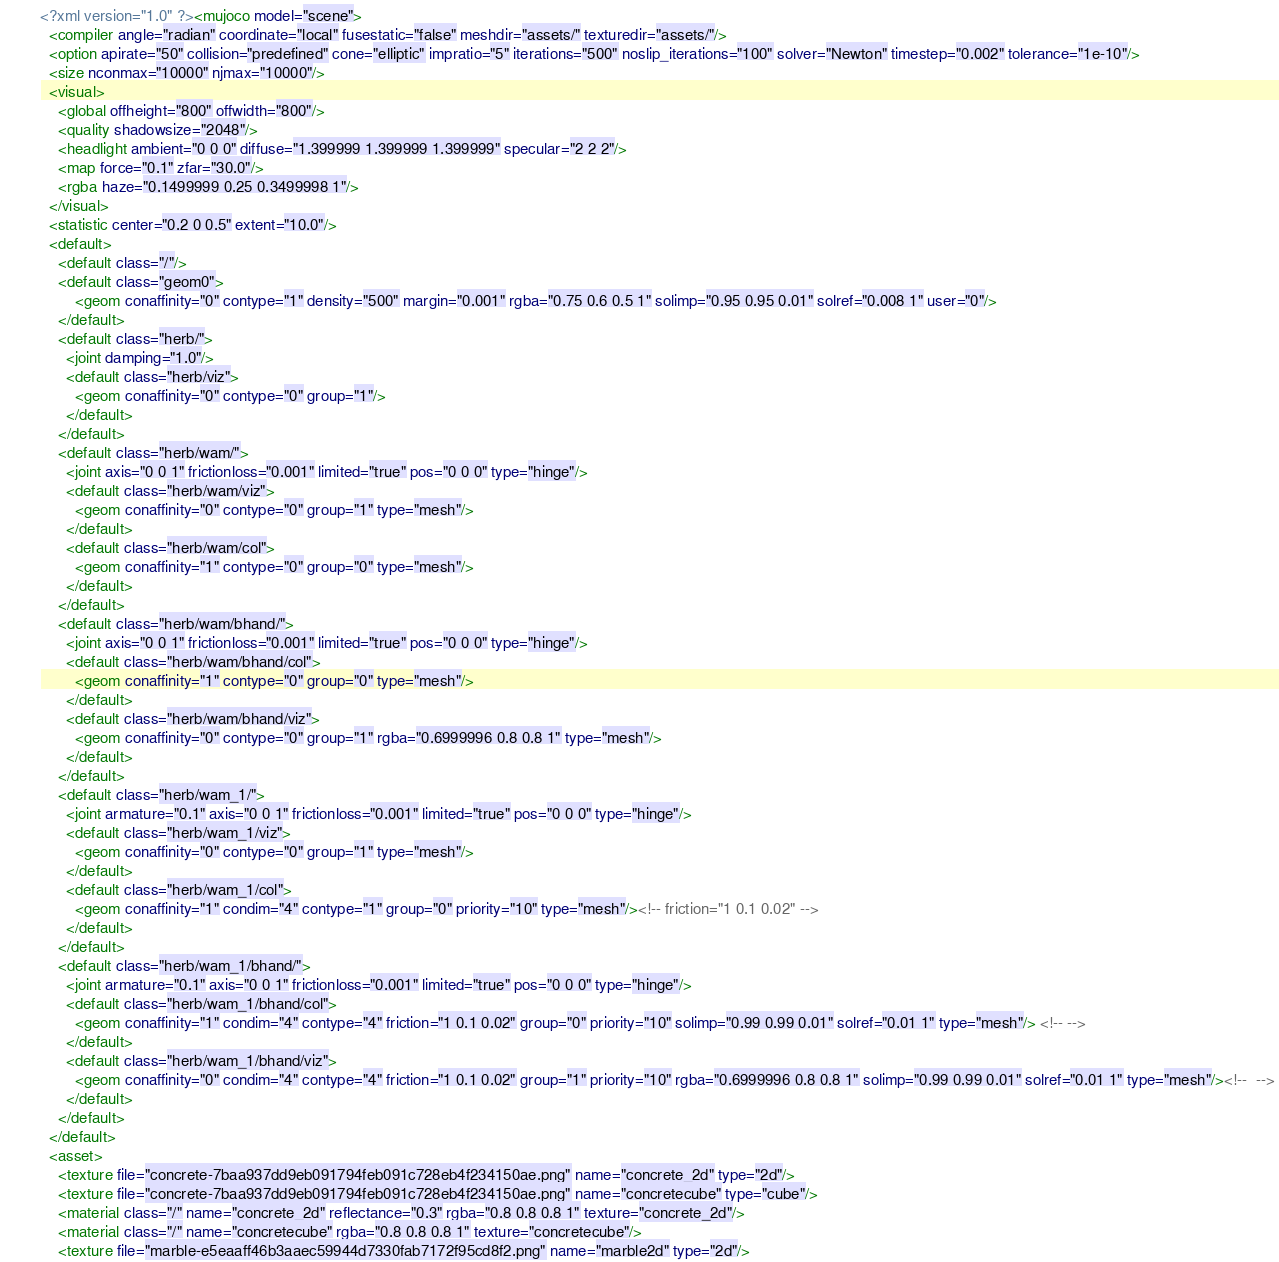Convert code to text. <code><loc_0><loc_0><loc_500><loc_500><_XML_><?xml version="1.0" ?><mujoco model="scene">
  <compiler angle="radian" coordinate="local" fusestatic="false" meshdir="assets/" texturedir="assets/"/>
  <option apirate="50" collision="predefined" cone="elliptic" impratio="5" iterations="500" noslip_iterations="100" solver="Newton" timestep="0.002" tolerance="1e-10"/>
  <size nconmax="10000" njmax="10000"/>
  <visual>
    <global offheight="800" offwidth="800"/>
    <quality shadowsize="2048"/>
    <headlight ambient="0 0 0" diffuse="1.399999 1.399999 1.399999" specular="2 2 2"/>
    <map force="0.1" zfar="30.0"/>
    <rgba haze="0.1499999 0.25 0.3499998 1"/>
  </visual>
  <statistic center="0.2 0 0.5" extent="10.0"/>
  <default>
    <default class="/"/>
    <default class="geom0">
        <geom conaffinity="0" contype="1" density="500" margin="0.001" rgba="0.75 0.6 0.5 1" solimp="0.95 0.95 0.01" solref="0.008 1" user="0"/>
    </default>
    <default class="herb/">
      <joint damping="1.0"/>
      <default class="herb/viz">
        <geom conaffinity="0" contype="0" group="1"/>
      </default>
    </default>
    <default class="herb/wam/">
      <joint axis="0 0 1" frictionloss="0.001" limited="true" pos="0 0 0" type="hinge"/>
      <default class="herb/wam/viz">
        <geom conaffinity="0" contype="0" group="1" type="mesh"/>
      </default>
      <default class="herb/wam/col">
        <geom conaffinity="1" contype="0" group="0" type="mesh"/>
      </default>
    </default>
    <default class="herb/wam/bhand/">
      <joint axis="0 0 1" frictionloss="0.001" limited="true" pos="0 0 0" type="hinge"/>
      <default class="herb/wam/bhand/col">
        <geom conaffinity="1" contype="0" group="0" type="mesh"/>
      </default>
      <default class="herb/wam/bhand/viz">
        <geom conaffinity="0" contype="0" group="1" rgba="0.6999996 0.8 0.8 1" type="mesh"/>
      </default>
    </default>
    <default class="herb/wam_1/">
      <joint armature="0.1" axis="0 0 1" frictionloss="0.001" limited="true" pos="0 0 0" type="hinge"/>
      <default class="herb/wam_1/viz">
        <geom conaffinity="0" contype="0" group="1" type="mesh"/>
      </default>
      <default class="herb/wam_1/col">
        <geom conaffinity="1" condim="4" contype="1" group="0" priority="10" type="mesh"/><!-- friction="1 0.1 0.02" -->
      </default>
    </default>
    <default class="herb/wam_1/bhand/">
      <joint armature="0.1" axis="0 0 1" frictionloss="0.001" limited="true" pos="0 0 0" type="hinge"/>
      <default class="herb/wam_1/bhand/col">
        <geom conaffinity="1" condim="4" contype="4" friction="1 0.1 0.02" group="0" priority="10" solimp="0.99 0.99 0.01" solref="0.01 1" type="mesh"/> <!-- -->
      </default> 
      <default class="herb/wam_1/bhand/viz">
        <geom conaffinity="0" condim="4" contype="4" friction="1 0.1 0.02" group="1" priority="10" rgba="0.6999996 0.8 0.8 1" solimp="0.99 0.99 0.01" solref="0.01 1" type="mesh"/><!--  -->
      </default>
    </default>
  </default>
  <asset>
    <texture file="concrete-7baa937dd9eb091794feb091c728eb4f234150ae.png" name="concrete_2d" type="2d"/>
    <texture file="concrete-7baa937dd9eb091794feb091c728eb4f234150ae.png" name="concretecube" type="cube"/>
    <material class="/" name="concrete_2d" reflectance="0.3" rgba="0.8 0.8 0.8 1" texture="concrete_2d"/>
    <material class="/" name="concretecube" rgba="0.8 0.8 0.8 1" texture="concretecube"/>
    <texture file="marble-e5eaaff46b3aaec59944d7330fab7172f95cd8f2.png" name="marble2d" type="2d"/></code> 